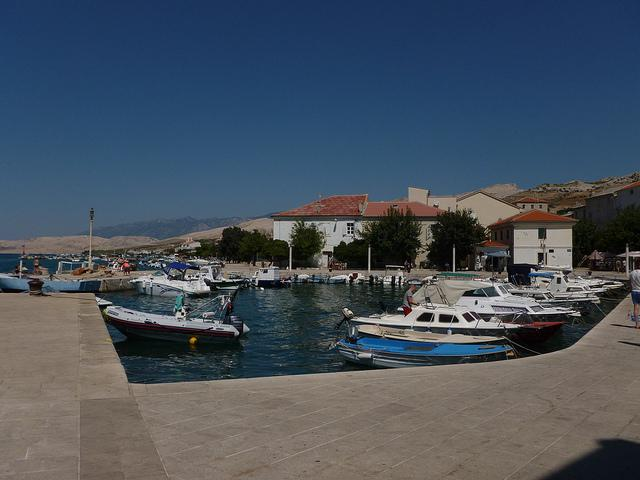What color is the top of the speed boat that is closest to the corner of the dock?

Choices:
A) orange
B) blue
C) white
D) tan blue 